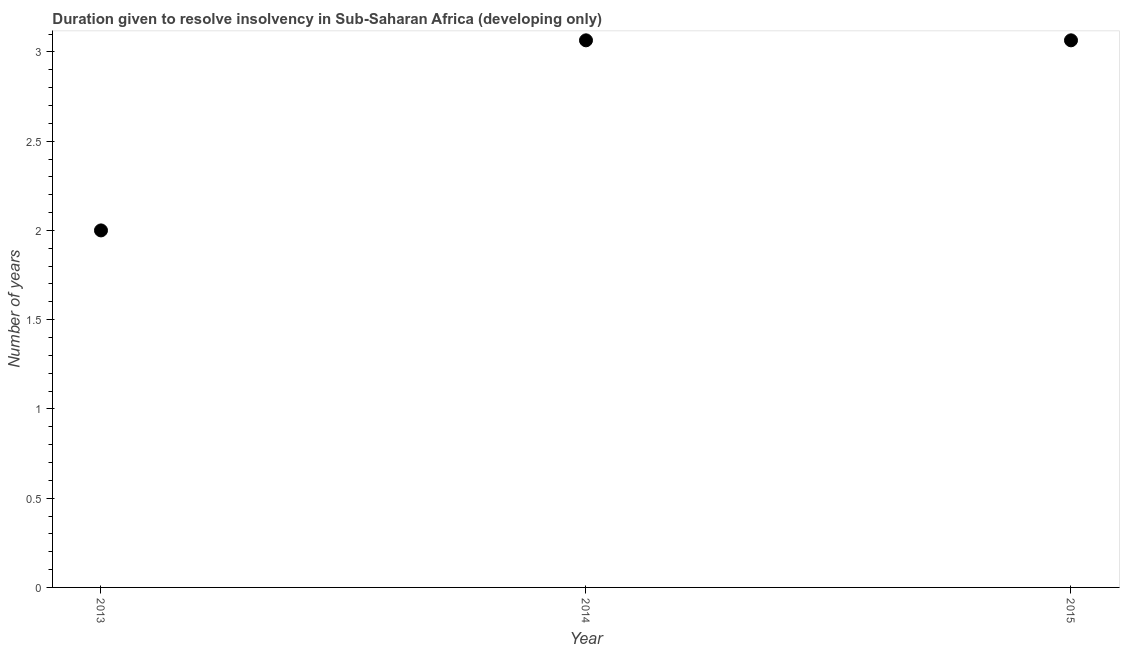Across all years, what is the maximum number of years to resolve insolvency?
Offer a very short reply. 3.06. In which year was the number of years to resolve insolvency minimum?
Offer a terse response. 2013. What is the sum of the number of years to resolve insolvency?
Offer a terse response. 8.13. What is the difference between the number of years to resolve insolvency in 2013 and 2015?
Ensure brevity in your answer.  -1.06. What is the average number of years to resolve insolvency per year?
Offer a terse response. 2.71. What is the median number of years to resolve insolvency?
Make the answer very short. 3.06. Do a majority of the years between 2015 and 2013 (inclusive) have number of years to resolve insolvency greater than 2 ?
Keep it short and to the point. No. What is the ratio of the number of years to resolve insolvency in 2013 to that in 2015?
Offer a terse response. 0.65. Is the number of years to resolve insolvency in 2014 less than that in 2015?
Provide a short and direct response. No. Is the difference between the number of years to resolve insolvency in 2013 and 2014 greater than the difference between any two years?
Provide a short and direct response. Yes. Is the sum of the number of years to resolve insolvency in 2013 and 2015 greater than the maximum number of years to resolve insolvency across all years?
Give a very brief answer. Yes. What is the difference between the highest and the lowest number of years to resolve insolvency?
Give a very brief answer. 1.06. In how many years, is the number of years to resolve insolvency greater than the average number of years to resolve insolvency taken over all years?
Your response must be concise. 2. How many years are there in the graph?
Your answer should be compact. 3. What is the title of the graph?
Provide a short and direct response. Duration given to resolve insolvency in Sub-Saharan Africa (developing only). What is the label or title of the X-axis?
Your answer should be compact. Year. What is the label or title of the Y-axis?
Offer a very short reply. Number of years. What is the Number of years in 2014?
Your response must be concise. 3.06. What is the Number of years in 2015?
Offer a terse response. 3.06. What is the difference between the Number of years in 2013 and 2014?
Offer a very short reply. -1.06. What is the difference between the Number of years in 2013 and 2015?
Keep it short and to the point. -1.06. What is the ratio of the Number of years in 2013 to that in 2014?
Provide a succinct answer. 0.65. What is the ratio of the Number of years in 2013 to that in 2015?
Your response must be concise. 0.65. What is the ratio of the Number of years in 2014 to that in 2015?
Offer a terse response. 1. 